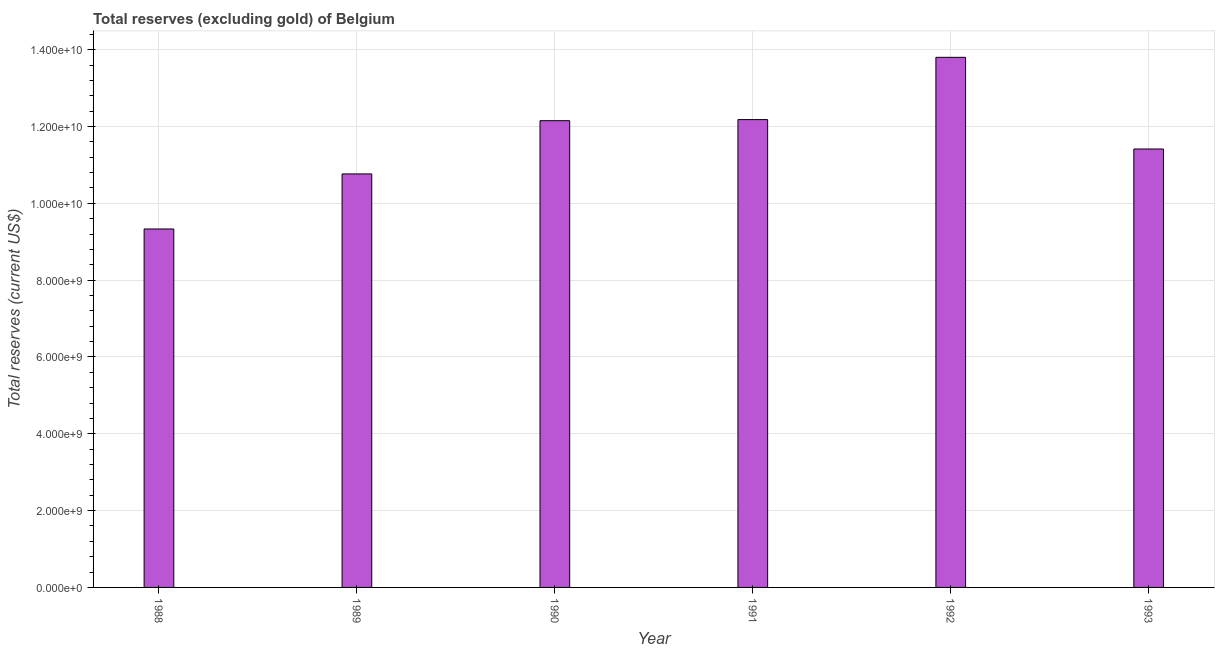Does the graph contain any zero values?
Provide a succinct answer. No. Does the graph contain grids?
Provide a succinct answer. Yes. What is the title of the graph?
Your response must be concise. Total reserves (excluding gold) of Belgium. What is the label or title of the X-axis?
Your answer should be compact. Year. What is the label or title of the Y-axis?
Offer a very short reply. Total reserves (current US$). What is the total reserves (excluding gold) in 1991?
Your answer should be very brief. 1.22e+1. Across all years, what is the maximum total reserves (excluding gold)?
Provide a short and direct response. 1.38e+1. Across all years, what is the minimum total reserves (excluding gold)?
Give a very brief answer. 9.33e+09. In which year was the total reserves (excluding gold) maximum?
Your answer should be very brief. 1992. What is the sum of the total reserves (excluding gold)?
Provide a short and direct response. 6.96e+1. What is the difference between the total reserves (excluding gold) in 1989 and 1993?
Give a very brief answer. -6.49e+08. What is the average total reserves (excluding gold) per year?
Your response must be concise. 1.16e+1. What is the median total reserves (excluding gold)?
Make the answer very short. 1.18e+1. Is the total reserves (excluding gold) in 1988 less than that in 1989?
Offer a very short reply. Yes. Is the difference between the total reserves (excluding gold) in 1989 and 1993 greater than the difference between any two years?
Make the answer very short. No. What is the difference between the highest and the second highest total reserves (excluding gold)?
Offer a very short reply. 1.62e+09. Is the sum of the total reserves (excluding gold) in 1990 and 1991 greater than the maximum total reserves (excluding gold) across all years?
Offer a terse response. Yes. What is the difference between the highest and the lowest total reserves (excluding gold)?
Keep it short and to the point. 4.47e+09. In how many years, is the total reserves (excluding gold) greater than the average total reserves (excluding gold) taken over all years?
Provide a succinct answer. 3. How many bars are there?
Your response must be concise. 6. How many years are there in the graph?
Offer a very short reply. 6. Are the values on the major ticks of Y-axis written in scientific E-notation?
Keep it short and to the point. Yes. What is the Total reserves (current US$) in 1988?
Your answer should be very brief. 9.33e+09. What is the Total reserves (current US$) of 1989?
Provide a short and direct response. 1.08e+1. What is the Total reserves (current US$) of 1990?
Your answer should be very brief. 1.22e+1. What is the Total reserves (current US$) in 1991?
Provide a short and direct response. 1.22e+1. What is the Total reserves (current US$) of 1992?
Provide a short and direct response. 1.38e+1. What is the Total reserves (current US$) in 1993?
Ensure brevity in your answer.  1.14e+1. What is the difference between the Total reserves (current US$) in 1988 and 1989?
Provide a short and direct response. -1.43e+09. What is the difference between the Total reserves (current US$) in 1988 and 1990?
Keep it short and to the point. -2.82e+09. What is the difference between the Total reserves (current US$) in 1988 and 1991?
Provide a succinct answer. -2.85e+09. What is the difference between the Total reserves (current US$) in 1988 and 1992?
Offer a very short reply. -4.47e+09. What is the difference between the Total reserves (current US$) in 1988 and 1993?
Your answer should be compact. -2.08e+09. What is the difference between the Total reserves (current US$) in 1989 and 1990?
Offer a very short reply. -1.39e+09. What is the difference between the Total reserves (current US$) in 1989 and 1991?
Offer a terse response. -1.41e+09. What is the difference between the Total reserves (current US$) in 1989 and 1992?
Ensure brevity in your answer.  -3.04e+09. What is the difference between the Total reserves (current US$) in 1989 and 1993?
Offer a very short reply. -6.49e+08. What is the difference between the Total reserves (current US$) in 1990 and 1991?
Provide a short and direct response. -2.88e+07. What is the difference between the Total reserves (current US$) in 1990 and 1992?
Keep it short and to the point. -1.65e+09. What is the difference between the Total reserves (current US$) in 1990 and 1993?
Your answer should be compact. 7.37e+08. What is the difference between the Total reserves (current US$) in 1991 and 1992?
Give a very brief answer. -1.62e+09. What is the difference between the Total reserves (current US$) in 1991 and 1993?
Your answer should be very brief. 7.66e+08. What is the difference between the Total reserves (current US$) in 1992 and 1993?
Give a very brief answer. 2.39e+09. What is the ratio of the Total reserves (current US$) in 1988 to that in 1989?
Your answer should be very brief. 0.87. What is the ratio of the Total reserves (current US$) in 1988 to that in 1990?
Your response must be concise. 0.77. What is the ratio of the Total reserves (current US$) in 1988 to that in 1991?
Make the answer very short. 0.77. What is the ratio of the Total reserves (current US$) in 1988 to that in 1992?
Keep it short and to the point. 0.68. What is the ratio of the Total reserves (current US$) in 1988 to that in 1993?
Your response must be concise. 0.82. What is the ratio of the Total reserves (current US$) in 1989 to that in 1990?
Ensure brevity in your answer.  0.89. What is the ratio of the Total reserves (current US$) in 1989 to that in 1991?
Give a very brief answer. 0.88. What is the ratio of the Total reserves (current US$) in 1989 to that in 1992?
Your response must be concise. 0.78. What is the ratio of the Total reserves (current US$) in 1989 to that in 1993?
Provide a short and direct response. 0.94. What is the ratio of the Total reserves (current US$) in 1990 to that in 1991?
Your response must be concise. 1. What is the ratio of the Total reserves (current US$) in 1990 to that in 1992?
Ensure brevity in your answer.  0.88. What is the ratio of the Total reserves (current US$) in 1990 to that in 1993?
Provide a short and direct response. 1.06. What is the ratio of the Total reserves (current US$) in 1991 to that in 1992?
Your response must be concise. 0.88. What is the ratio of the Total reserves (current US$) in 1991 to that in 1993?
Make the answer very short. 1.07. What is the ratio of the Total reserves (current US$) in 1992 to that in 1993?
Give a very brief answer. 1.21. 